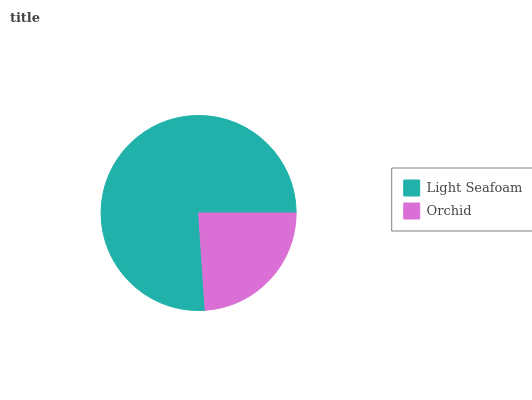Is Orchid the minimum?
Answer yes or no. Yes. Is Light Seafoam the maximum?
Answer yes or no. Yes. Is Orchid the maximum?
Answer yes or no. No. Is Light Seafoam greater than Orchid?
Answer yes or no. Yes. Is Orchid less than Light Seafoam?
Answer yes or no. Yes. Is Orchid greater than Light Seafoam?
Answer yes or no. No. Is Light Seafoam less than Orchid?
Answer yes or no. No. Is Light Seafoam the high median?
Answer yes or no. Yes. Is Orchid the low median?
Answer yes or no. Yes. Is Orchid the high median?
Answer yes or no. No. Is Light Seafoam the low median?
Answer yes or no. No. 